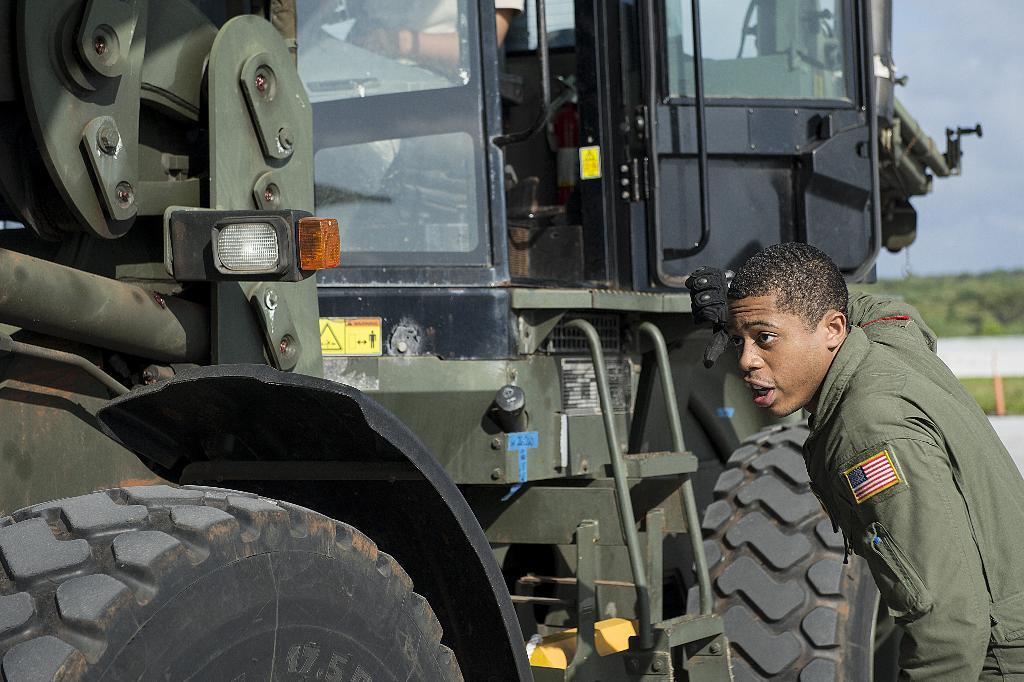What is the main subject of the image? There is a vehicle in the image. Can you describe the people in the image? A person is sitting inside the vehicle, and there is a person standing beside the vehicle. What can be seen in the background of the image? The sky is visible in the image. What type of jam is being spread on the face of the person sitting inside the vehicle? There is no jam or face-spreading activity present in the image. 